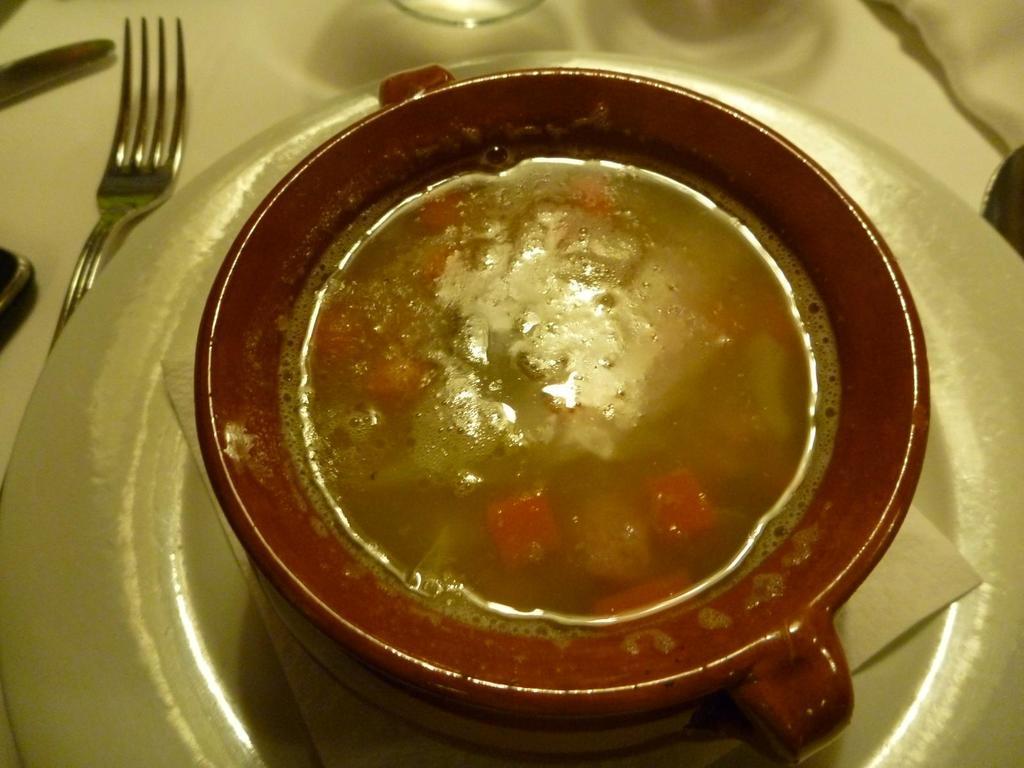How would you summarize this image in a sentence or two? Here we can see a plate, tissue paper, cup, fork, and food on a platform. 